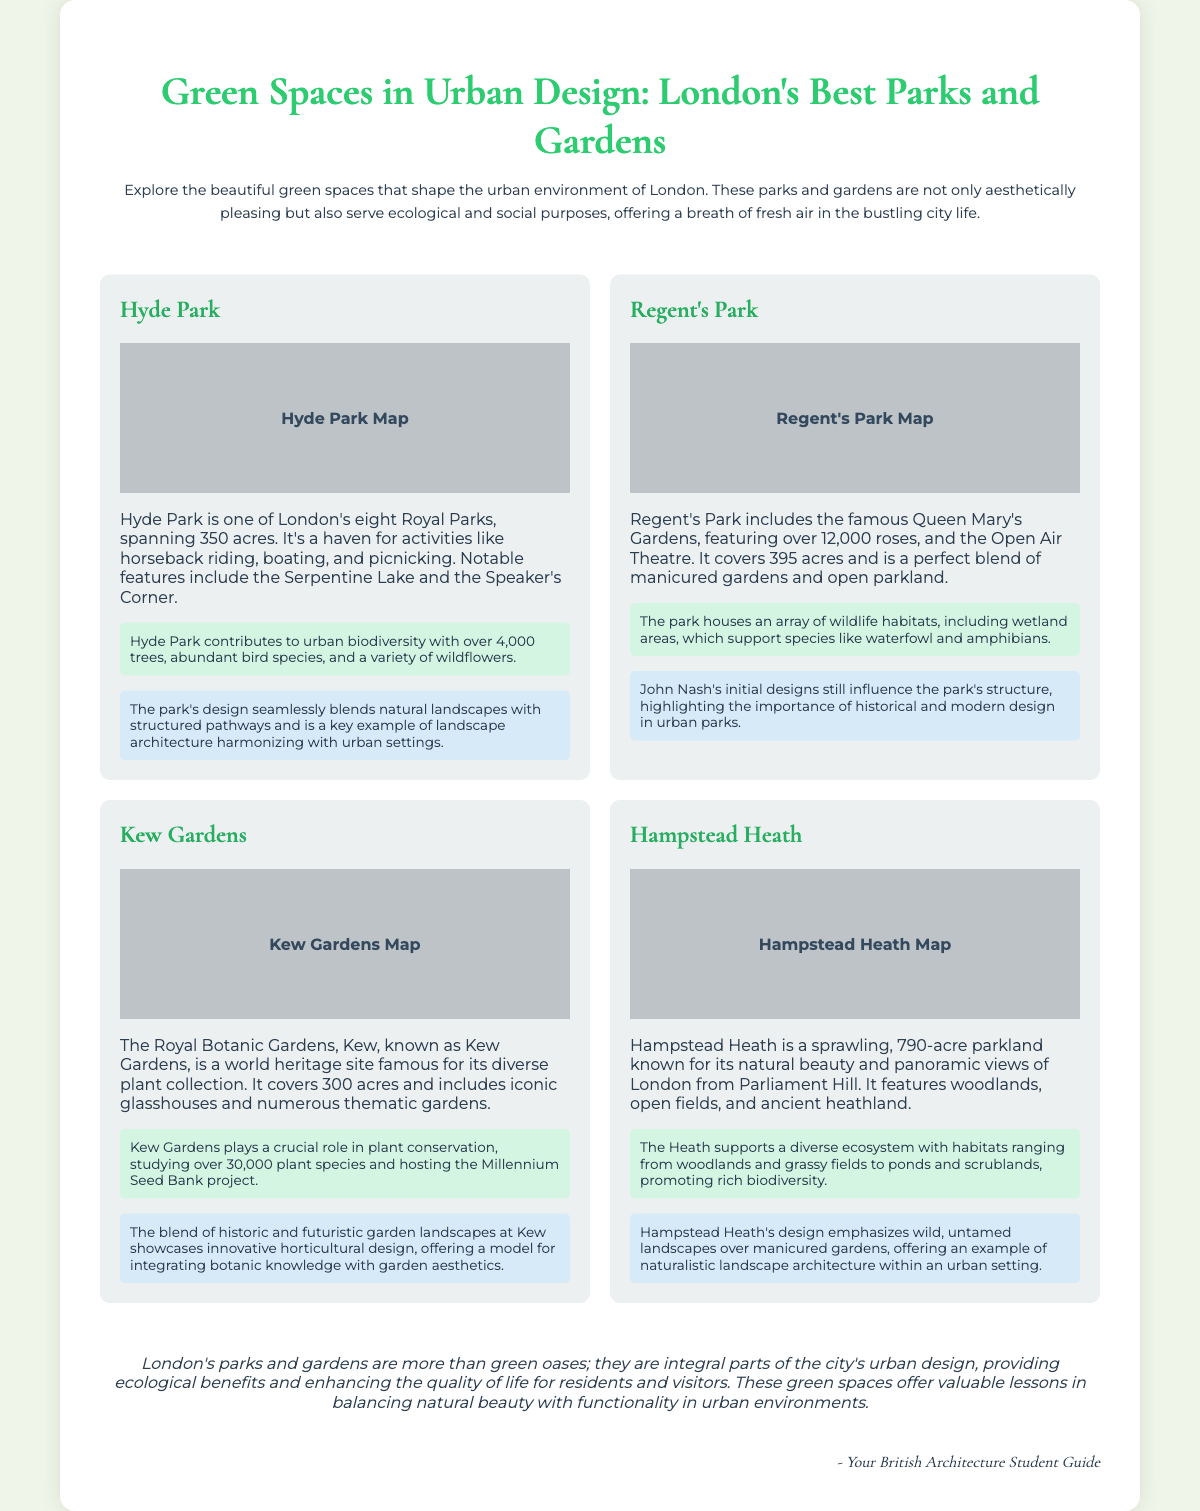What is the area of Hyde Park? The area of Hyde Park is stated to be 350 acres in the document.
Answer: 350 acres Which park is known for its Open Air Theatre? The document specifically mentions that Regent's Park includes the famous Open Air Theatre.
Answer: Regent's Park How many rose species are found in Queen Mary's Gardens? According to the document, Queen Mary's Gardens features over 12,000 roses.
Answer: 12,000 roses What significant ecological project does Kew Gardens host? The document states that Kew Gardens hosts the Millennium Seed Bank project.
Answer: Millennium Seed Bank Which park covers 790 acres? The document describes Hampstead Heath as a sprawling parkland that covers 790 acres.
Answer: Hampstead Heath What design element is emphasized in Hampstead Heath? The document mentions that Hampstead Heath's design emphasizes wild, untamed landscapes.
Answer: Wild, untamed landscapes What is the primary ecological benefit of Hyde Park? The document notes that Hyde Park contributes to urban biodiversity with over 4,000 trees.
Answer: Over 4,000 trees What is the conclusion about London's parks and gardens? The document concludes that London's parks and gardens are integral parts of the city's urban design.
Answer: Integral parts of the city's urban design Who authored the document? The document is signed off by "Your British Architecture Student Guide" as the author.
Answer: Your British Architecture Student Guide 